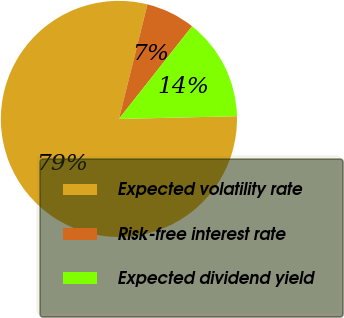<chart> <loc_0><loc_0><loc_500><loc_500><pie_chart><fcel>Expected volatility rate<fcel>Risk-free interest rate<fcel>Expected dividend yield<nl><fcel>79.24%<fcel>6.75%<fcel>14.0%<nl></chart> 